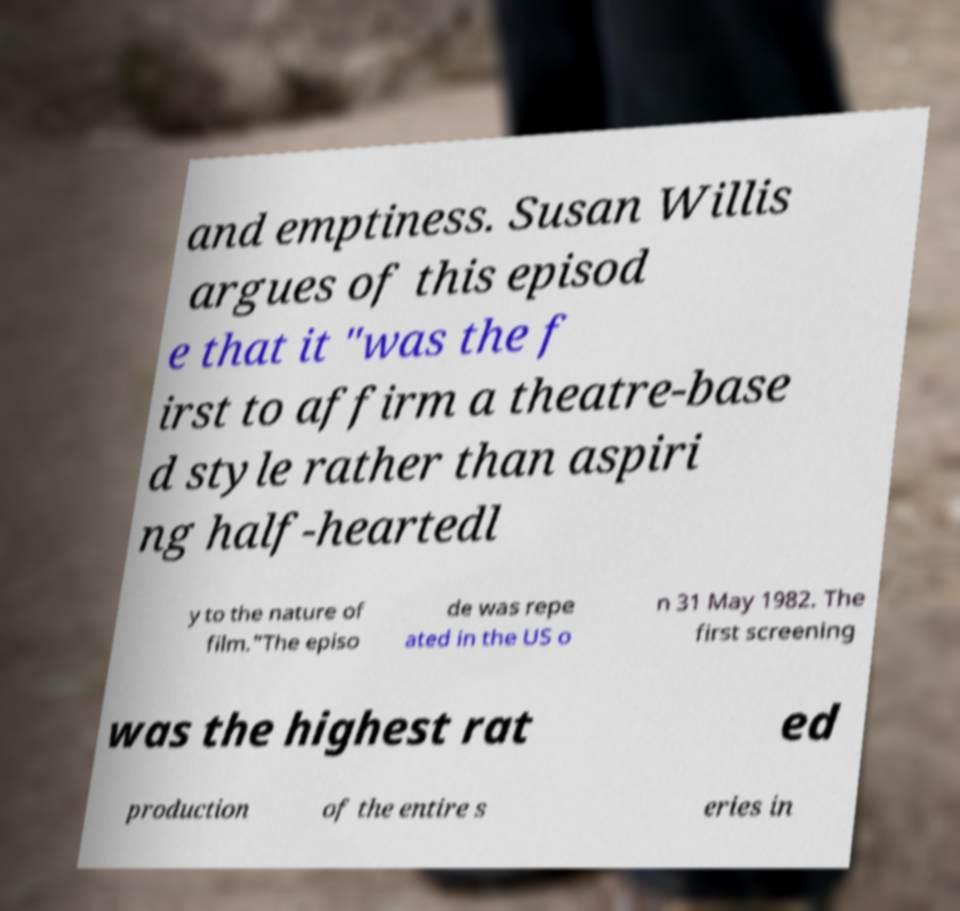For documentation purposes, I need the text within this image transcribed. Could you provide that? and emptiness. Susan Willis argues of this episod e that it "was the f irst to affirm a theatre-base d style rather than aspiri ng half-heartedl y to the nature of film."The episo de was repe ated in the US o n 31 May 1982. The first screening was the highest rat ed production of the entire s eries in 